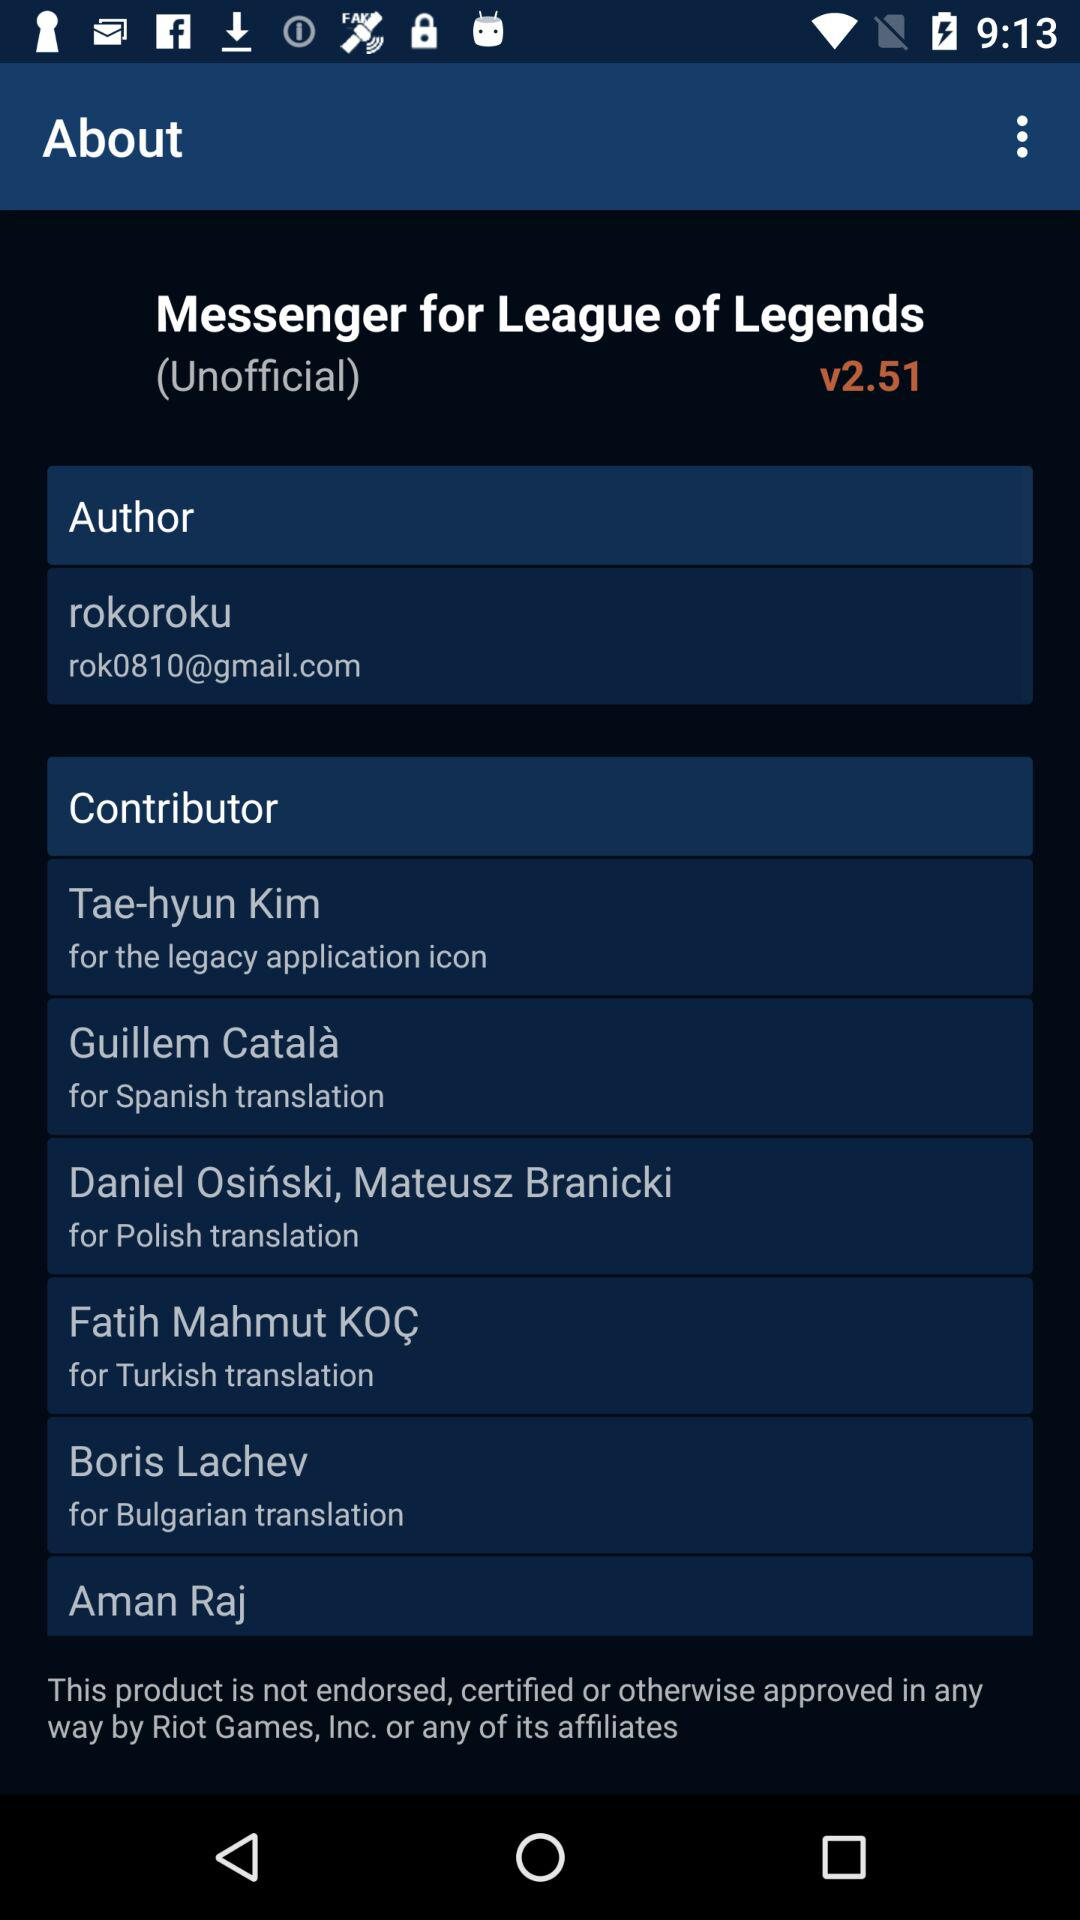Who is the author? The author is "rokoroku". 